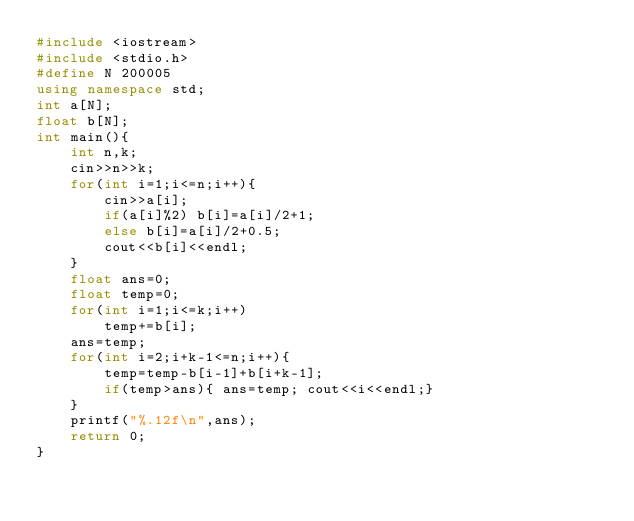Convert code to text. <code><loc_0><loc_0><loc_500><loc_500><_C++_>#include <iostream>
#include <stdio.h> 
#define N 200005
using namespace std;
int a[N];
float b[N];
int main(){
	int n,k;
	cin>>n>>k;
	for(int i=1;i<=n;i++){
		cin>>a[i];
		if(a[i]%2) b[i]=a[i]/2+1;
		else b[i]=a[i]/2+0.5;
		cout<<b[i]<<endl;
	}
	float ans=0;
	float temp=0;
	for(int i=1;i<=k;i++)
		temp+=b[i];
	ans=temp;
	for(int i=2;i+k-1<=n;i++){
		temp=temp-b[i-1]+b[i+k-1];
		if(temp>ans){ ans=temp;	cout<<i<<endl;}
	}
	printf("%.12f\n",ans);
	return 0;
}</code> 